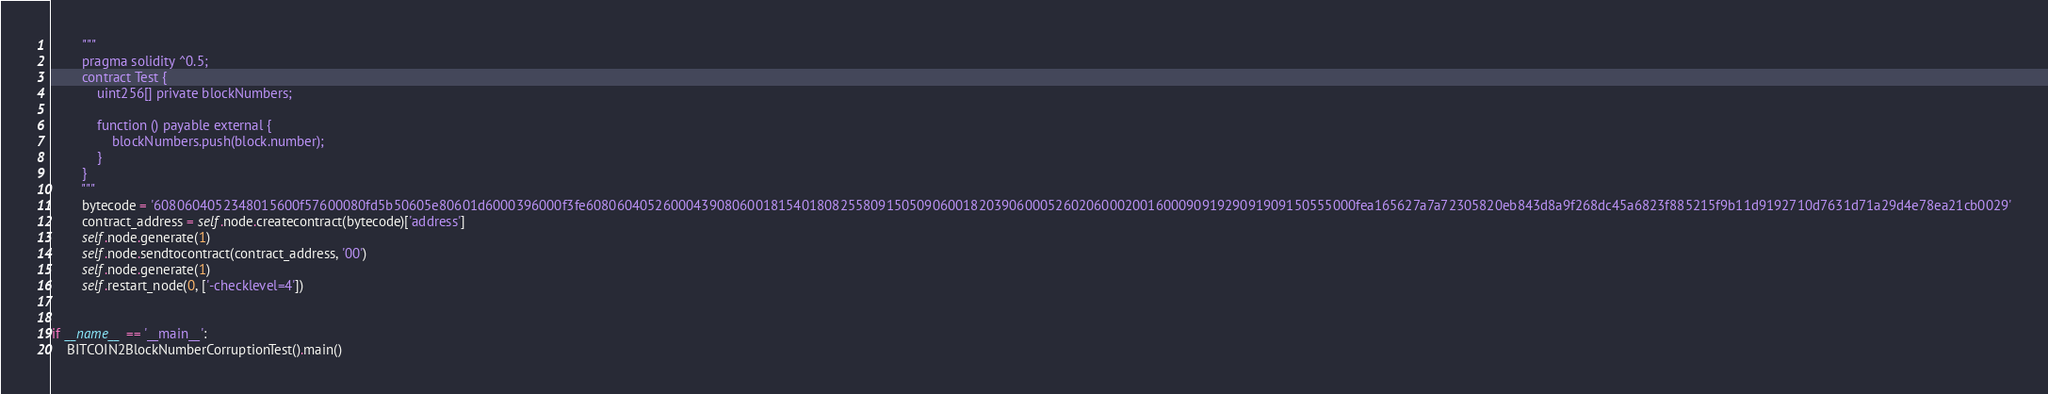<code> <loc_0><loc_0><loc_500><loc_500><_Python_>        """
        pragma solidity ^0.5;
        contract Test {
            uint256[] private blockNumbers;
            
            function () payable external {
                blockNumbers.push(block.number);
            }
        }
        """
        bytecode = '6080604052348015600f57600080fd5b50605e80601d6000396000f3fe6080604052600043908060018154018082558091505090600182039060005260206000200160009091929091909150555000fea165627a7a72305820eb843d8a9f268dc45a6823f885215f9b11d9192710d7631d71a29d4e78ea21cb0029'
        contract_address = self.node.createcontract(bytecode)['address']
        self.node.generate(1)
        self.node.sendtocontract(contract_address, '00')
        self.node.generate(1)
        self.restart_node(0, ['-checklevel=4'])


if __name__ == '__main__':
    BITCOIN2BlockNumberCorruptionTest().main()</code> 